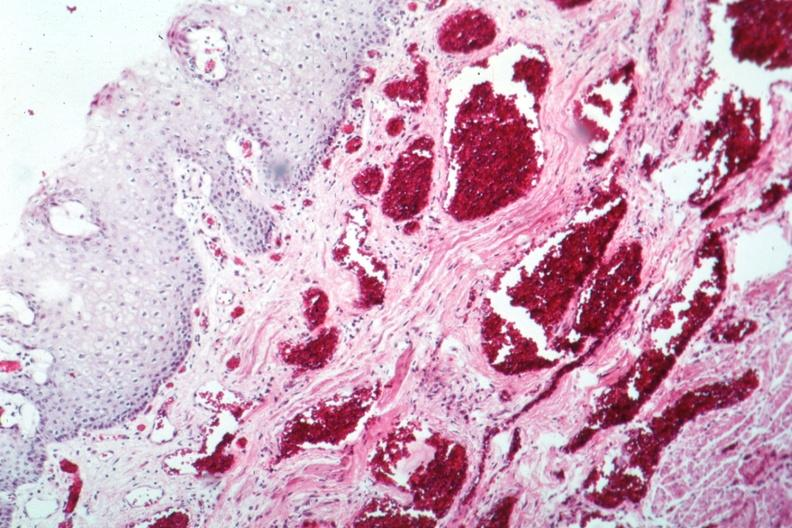what is present?
Answer the question using a single word or phrase. Varices 